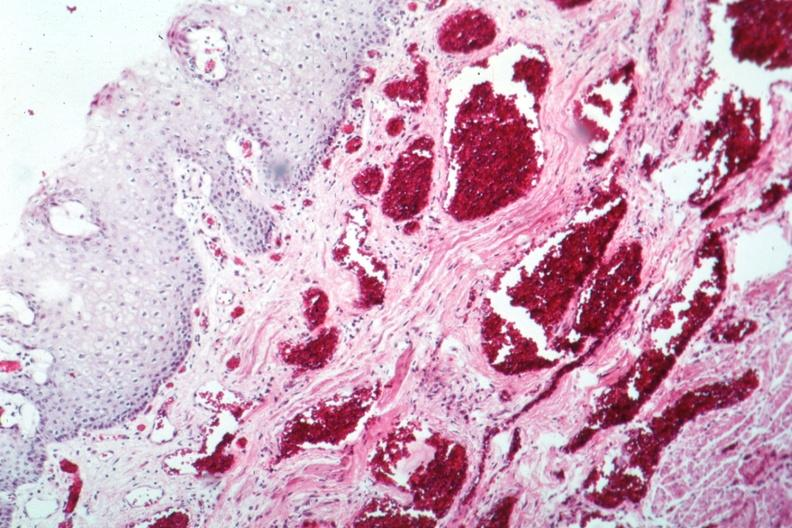what is present?
Answer the question using a single word or phrase. Varices 